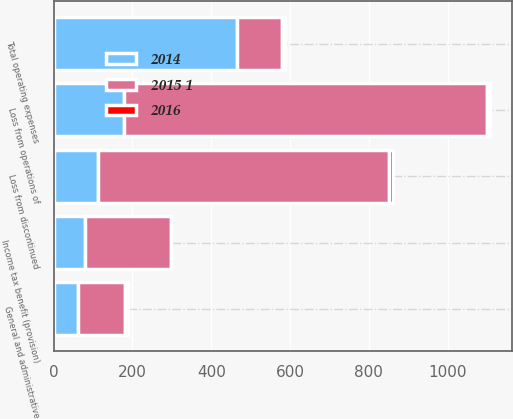Convert chart. <chart><loc_0><loc_0><loc_500><loc_500><stacked_bar_chart><ecel><fcel>General and administrative<fcel>Total operating expenses<fcel>Loss from operations of<fcel>Loss from discontinued<fcel>Income tax benefit (provision)<nl><fcel>2016<fcel>8<fcel>8<fcel>8<fcel>9<fcel>1<nl><fcel>2015 1<fcel>118<fcel>113<fcel>922<fcel>738<fcel>218<nl><fcel>2014<fcel>62<fcel>466<fcel>178<fcel>113<fcel>80<nl></chart> 